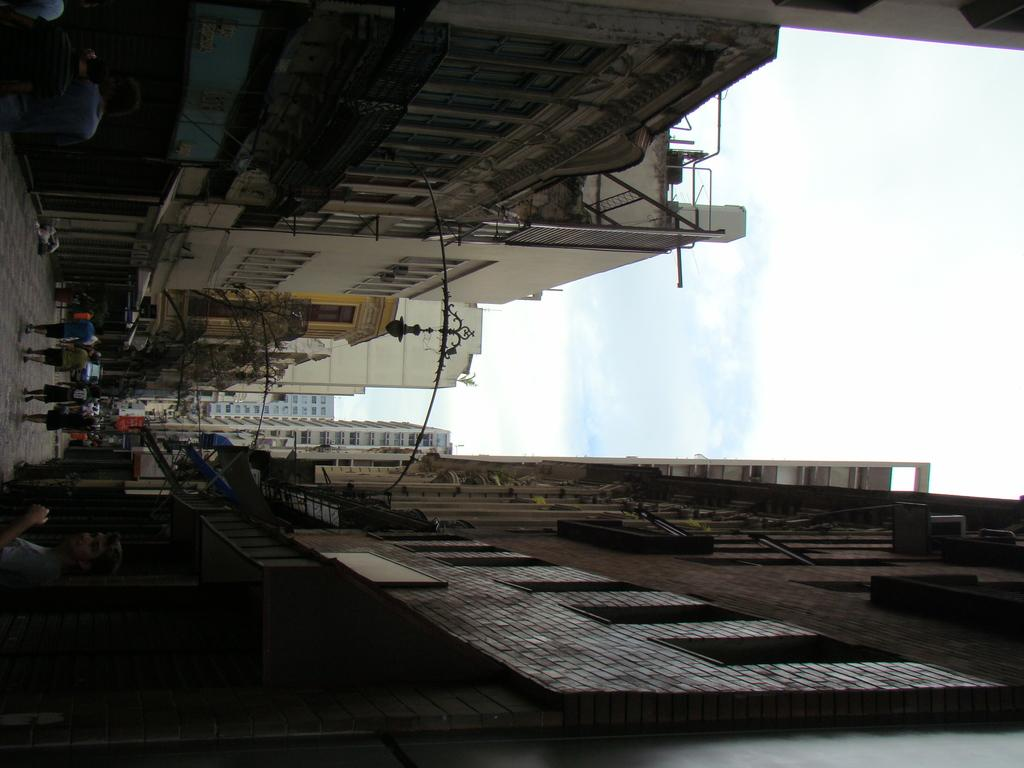What is located in the middle of the image? There are people in the middle of the image. What can be seen in the image besides the people? There are lights, a floor, and buildings at the bottom and top of the image. The sky is also visible at the top of the image, with clouds present. What type of education is being provided to the people in the image? There is no indication of education in the image; it simply shows people, lights, a floor, buildings, and the sky with clouds. What drug is being used by the people in the image? There is no drug present in the image; it does not depict any drug use. 